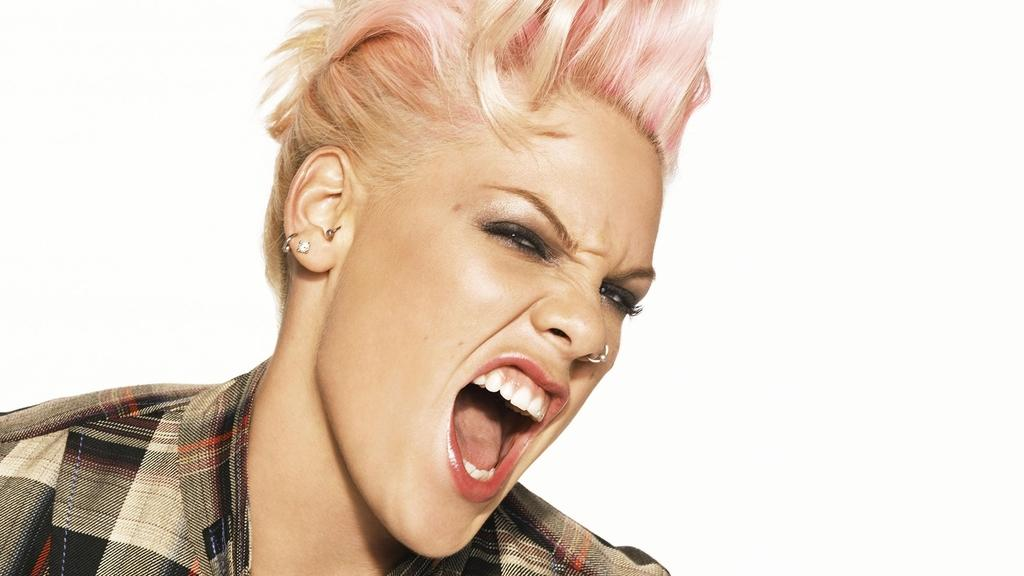Who is the main subject in the image? There is a woman in the image. What is the woman wearing? The woman is wearing a shirt. Can you describe any accessories the woman is wearing? The woman has a nose ring and earrings. What can be seen in the background of the image? There is brightness in the background of the image. What type of eggs can be seen in the image? There are no eggs present in the image. What kind of print is visible on the woman's shirt? The woman's shirt does not have any visible print. Are there any bricks visible in the image? There are no bricks present in the image. 